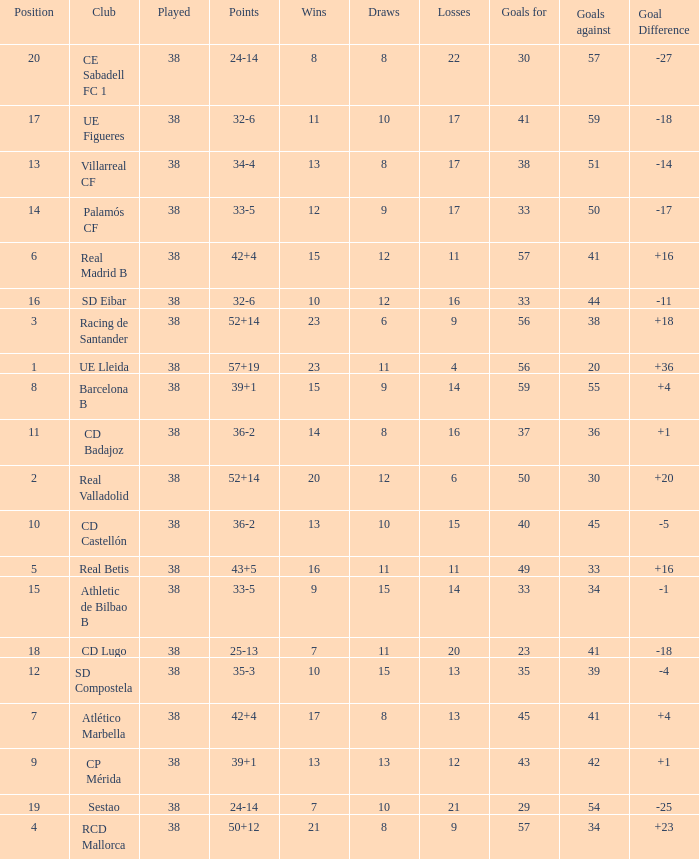What is the average goal difference with 51 goals scored against and less than 17 losses? None. 